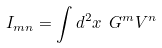<formula> <loc_0><loc_0><loc_500><loc_500>I _ { m n } = \int d ^ { 2 } x \ G ^ { m } V ^ { n }</formula> 